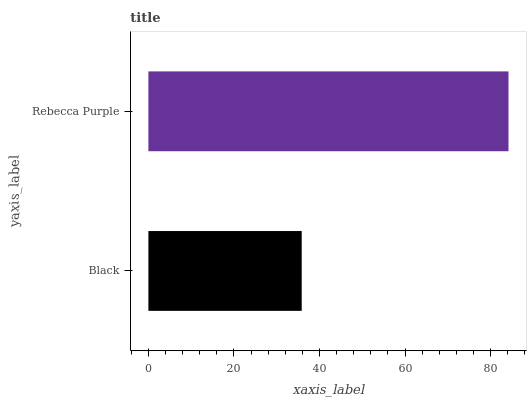Is Black the minimum?
Answer yes or no. Yes. Is Rebecca Purple the maximum?
Answer yes or no. Yes. Is Rebecca Purple the minimum?
Answer yes or no. No. Is Rebecca Purple greater than Black?
Answer yes or no. Yes. Is Black less than Rebecca Purple?
Answer yes or no. Yes. Is Black greater than Rebecca Purple?
Answer yes or no. No. Is Rebecca Purple less than Black?
Answer yes or no. No. Is Rebecca Purple the high median?
Answer yes or no. Yes. Is Black the low median?
Answer yes or no. Yes. Is Black the high median?
Answer yes or no. No. Is Rebecca Purple the low median?
Answer yes or no. No. 